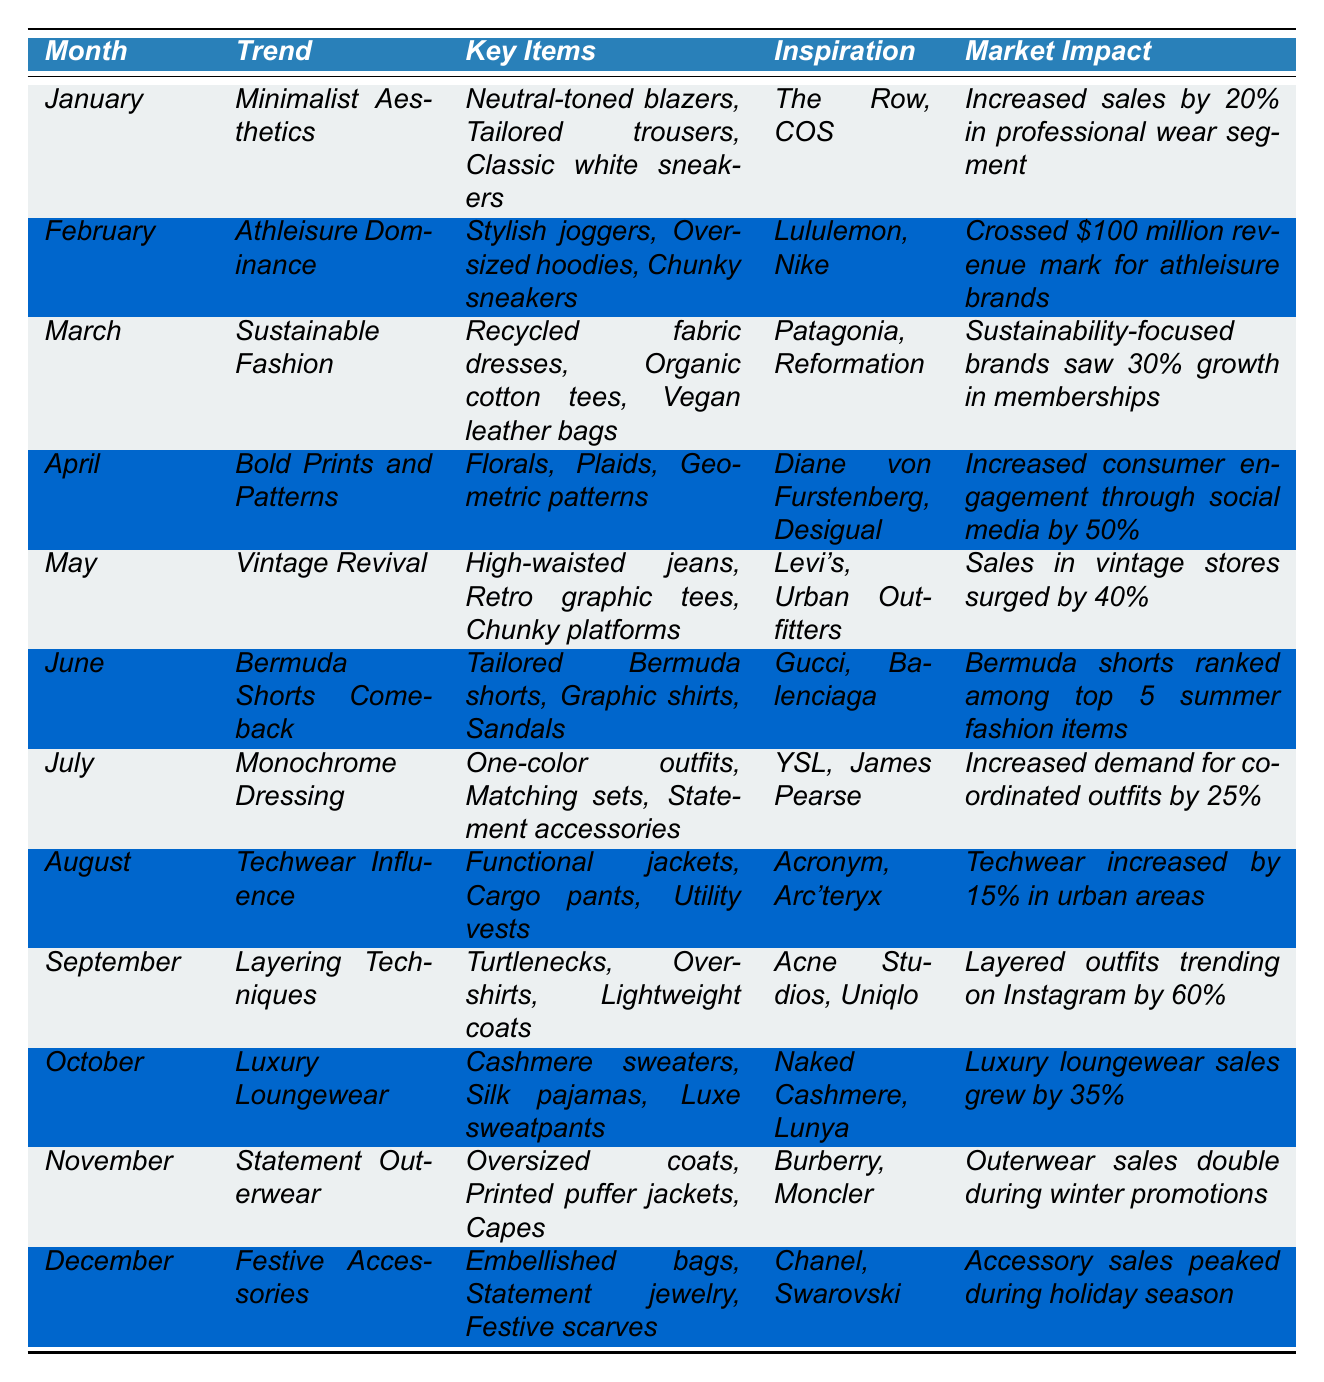What is the trend in January? The table provides the trend for each month. For January, the trend is "Minimalist Aesthetics."
Answer: Minimalist Aesthetics What key items are associated with the trend in March? The table lists the key items for each month's trend. For March, the key items are "Recycled fabric dresses, Organic cotton tees, Vegan leather bags."
Answer: Recycled fabric dresses, Organic cotton tees, Vegan leather bags Which month saw a 30% growth in memberships for sustainability-focused brands? By looking at the market impact, March indicates a 30% growth in memberships for sustainability-focused brands.
Answer: March What impact did the Bold Prints and Patterns trend have on consumer engagement in April? The table shows that consumer engagement increased through social media by 50% for the Bold Prints and Patterns trend in April.
Answer: Increased by 50% Which trend had the highest increase in sales percentage for vintage stores? The table indicates May's "Vintage Revival" trend, where sales in vintage stores surged by 40%.
Answer: Vintage Revival In which months did the athleisure trend generate over $100 million in revenue? According to the table, February is the month that crossed the $100 million revenue mark for athleisure brands.
Answer: February What percentage increase in sales was reported for luxury loungewear in October? The market impact for October indicates that luxury loungewear sales grew by 35%.
Answer: 35% How many trends resulted in increased demand for clothing based on the table? Looking through the trends, all except for January resulted in notable increases. Specifically, February, March, April, May, July, August, September, October, November, and December demonstrate increases, totaling 10 trends.
Answer: 10 Did layering techniques become popular on Instagram in September? Yes, according to the table, layered outfits trended on Instagram by 60% in September.
Answer: Yes Which two months had trends involving outerwear and their market impact? From November, we see "Statement Outerwear," and in October, "Luxury Loungewear" also involves warm clothing. The market impact in November reports doubled outerwear sales.
Answer: November What is the average percentage growth noted for the athleisure and luxury loungewear trends? For athleisure in February there is a notable impact of over $100 million revenue, while luxury loungewear in October shows a 35% growth. Calculating an average: (100% + 35%) / 2 = 67.5% growth.
Answer: 67.5% 